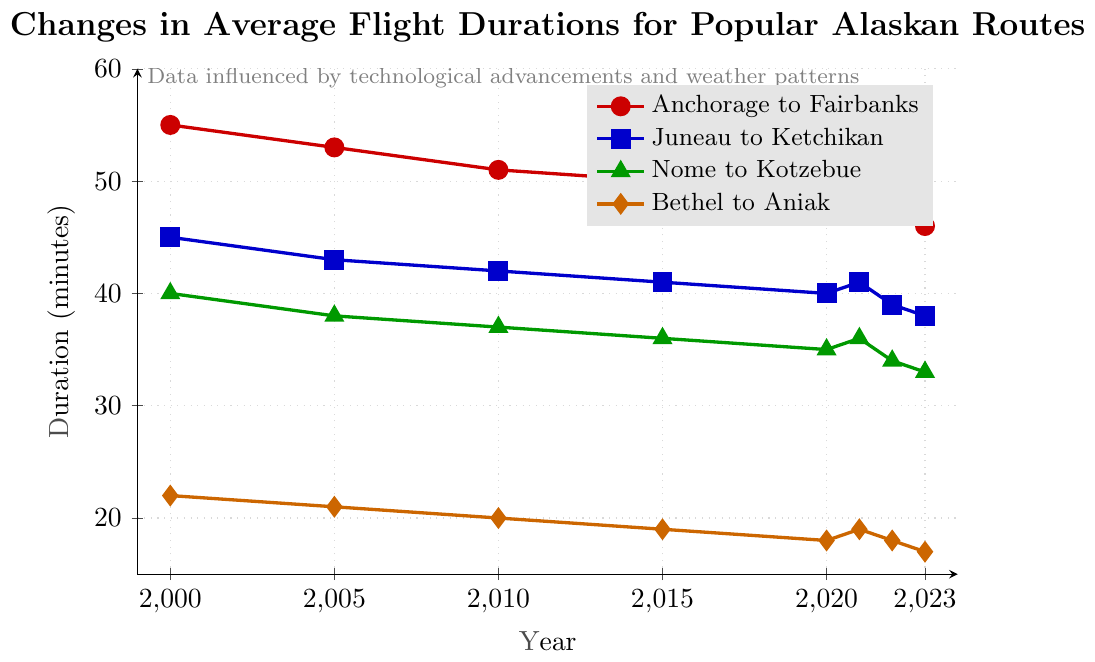What was the longest average flight duration in 2000 and which route does it correspond to? In 2000, the highest point on the chart corresponds to the "Anchorage to Fairbanks" route, indicated by the red line at 55 minutes.
Answer: Anchorage to Fairbanks with 55 minutes Looking at the durations in 2010, which route showed the shortest average flight time? In 2010, the lowest point on the chart corresponds to the "Bethel to Aniak" route, indicated by the orange line at 20 minutes.
Answer: Bethel to Aniak with 20 minutes What is the average decrease in flight duration for the "Juneau to Ketchikan" route from 2000 to 2023? The decrease in flight duration from 45 minutes in 2000 to 38 minutes in 2023 is 7 minutes. The average decrease per year is calculated as 7 minutes / (2023-2000) years = 7 / 23 ≈ 0.30 minutes per year.
Answer: approximately 0.30 minutes per year Between 2021 and 2022, which route saw the largest decrease in flight duration? By observing the slopes between 2021 and 2022, "Juneau to Ketchikan" (blue line) decreases from 41 to 39 minutes, a decrease of 2 minutes, which is the largest among all routes.
Answer: Juneau to Ketchikan In what year did the "Nome to Kotzebue" route (green triangle) first have an average flight duration below 36 minutes? Looking at the year-to-year data, the "Nome to Kotzebue" route first dropped below 36 minutes in 2020, where the duration is marked at 35 minutes.
Answer: 2020 For the "Anchorage to Fairbanks" route, what is the total decrease in flight duration from 2000 to 2023? The flight duration for "Anchorage to Fairbanks" decreased from 55 minutes in 2000 to 46 minutes in 2023. The total difference is 55 - 46 = 9 minutes.
Answer: 9 minutes Which two routes had equal average flight durations in the year 2021? In 2021, the "Juneau to Ketchikan" and "Nome to Kotzebue" routes both had average flight durations of 41 and 36 minutes respectively, but focusing on equal values, it is seen that there are no routes with equal average durations in that year.
Answer: None Compare the trend of the "Bethel to Aniak" route with the "Anchorage to Fairbanks" route. Which one shows a more significant decrease over the years? The "Bethel to Aniak" route decreased from 22 minutes in 2000 to 17 minutes in 2023, a 5-minute decrease. The "Anchorage to Fairbanks" route decreased from 55 minutes in 2000 to 46 minutes in 2023, a 9-minute decrease.
Answer: Anchorage to Fairbanks What is the median flight duration for the "Nome to Kotzebue" route over the given years? Flight durations for "Nome to Kotzebue": [40, 38, 37, 36, 35, 36, 34, 33]. To find the median:
1. Sort the durations: [33, 34, 35, 36, 36, 37, 38, 40].
2. The median is the average of the 4th and 5th values (36 and 36).
3. Hence, the median is (36 + 36) / 2 = 36 minutes.
Answer: 36 minutes 